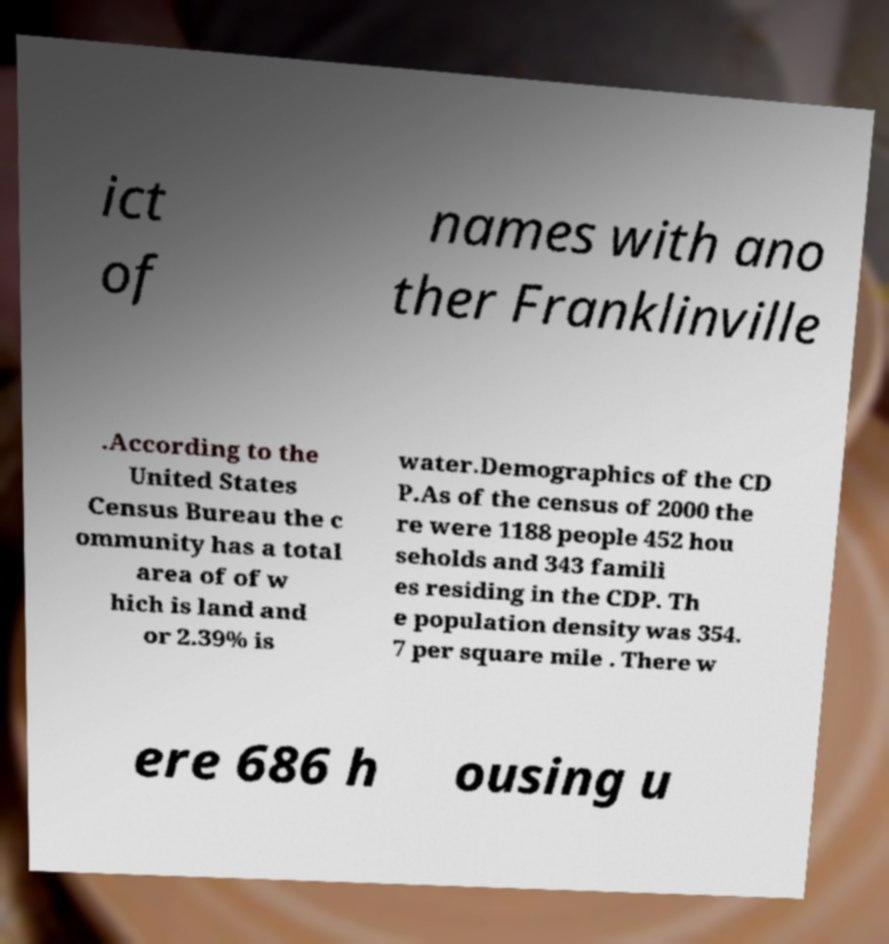Could you extract and type out the text from this image? ict of names with ano ther Franklinville .According to the United States Census Bureau the c ommunity has a total area of of w hich is land and or 2.39% is water.Demographics of the CD P.As of the census of 2000 the re were 1188 people 452 hou seholds and 343 famili es residing in the CDP. Th e population density was 354. 7 per square mile . There w ere 686 h ousing u 